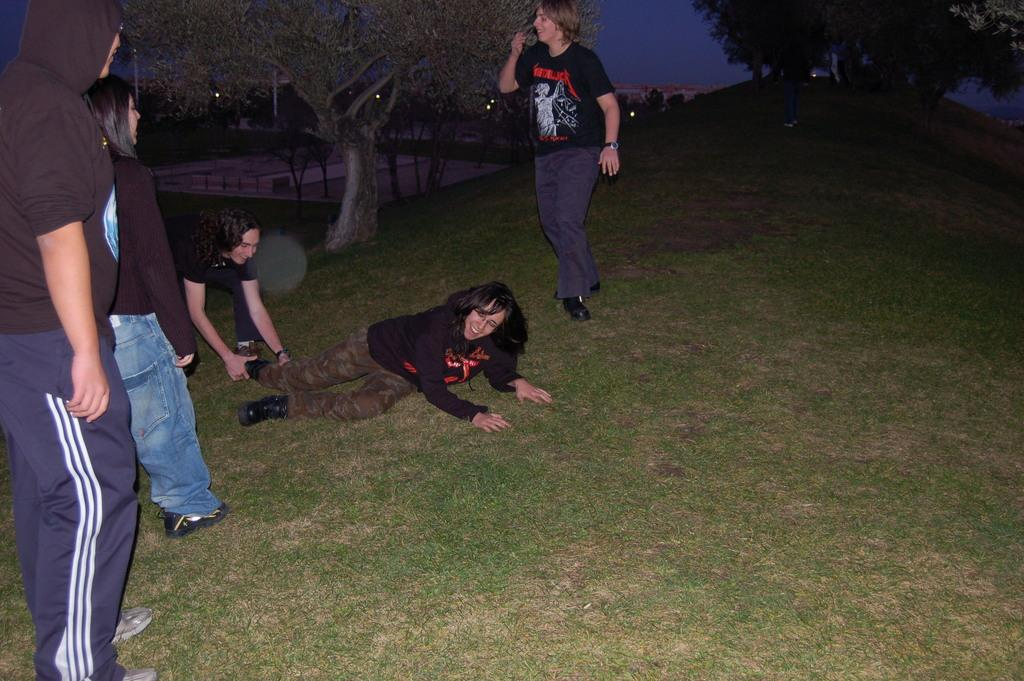What is the main subject of the image? The main subject of the image is a group of people. Can you describe the position of one of the individuals in the group? A woman is laying on the grass path. What can be seen in the background of the image? There are trees and the sky visible in the background of the image. What type of locket is the father wearing in the image? There is no father or locket present in the image. How many boots can be seen on the people in the image? There is no mention of boots in the image, so it cannot be determined how many boots are visible. 